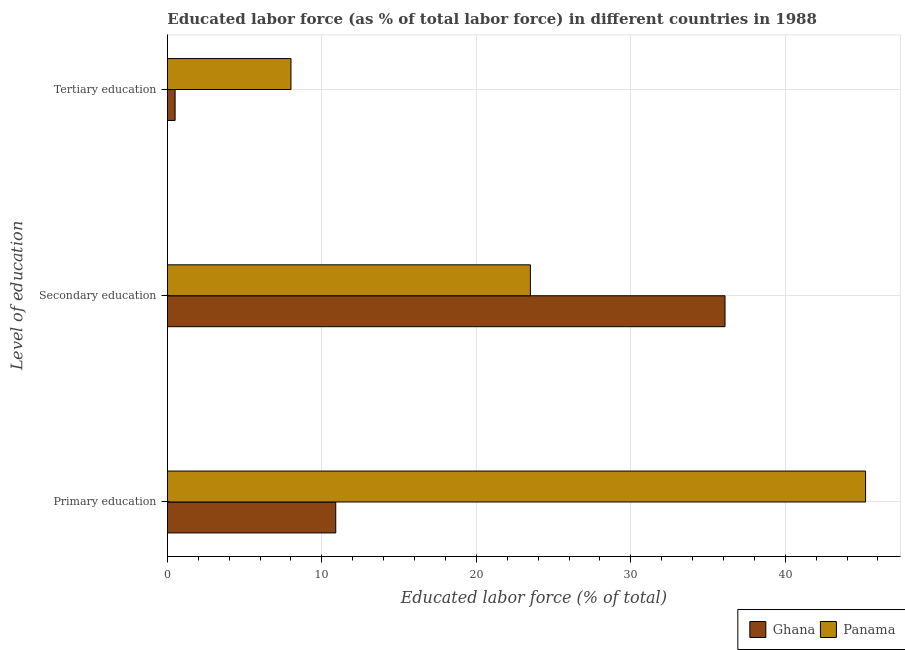How many different coloured bars are there?
Keep it short and to the point. 2. How many groups of bars are there?
Offer a terse response. 3. Are the number of bars per tick equal to the number of legend labels?
Provide a succinct answer. Yes. Are the number of bars on each tick of the Y-axis equal?
Provide a short and direct response. Yes. How many bars are there on the 2nd tick from the top?
Offer a very short reply. 2. How many bars are there on the 2nd tick from the bottom?
Your response must be concise. 2. What is the label of the 3rd group of bars from the top?
Ensure brevity in your answer.  Primary education. Across all countries, what is the maximum percentage of labor force who received secondary education?
Your answer should be compact. 36.1. Across all countries, what is the minimum percentage of labor force who received tertiary education?
Provide a succinct answer. 0.5. What is the total percentage of labor force who received tertiary education in the graph?
Offer a very short reply. 8.5. What is the difference between the percentage of labor force who received tertiary education in Ghana and that in Panama?
Your answer should be compact. -7.5. What is the difference between the percentage of labor force who received primary education in Ghana and the percentage of labor force who received tertiary education in Panama?
Your response must be concise. 2.9. What is the average percentage of labor force who received primary education per country?
Your response must be concise. 28.05. What is the difference between the percentage of labor force who received primary education and percentage of labor force who received secondary education in Panama?
Provide a short and direct response. 21.7. What is the ratio of the percentage of labor force who received primary education in Ghana to that in Panama?
Offer a very short reply. 0.24. Is the sum of the percentage of labor force who received primary education in Ghana and Panama greater than the maximum percentage of labor force who received tertiary education across all countries?
Your answer should be compact. Yes. What does the 2nd bar from the bottom in Secondary education represents?
Ensure brevity in your answer.  Panama. Are all the bars in the graph horizontal?
Keep it short and to the point. Yes. Are the values on the major ticks of X-axis written in scientific E-notation?
Make the answer very short. No. Does the graph contain any zero values?
Offer a very short reply. No. Does the graph contain grids?
Provide a short and direct response. Yes. Where does the legend appear in the graph?
Offer a very short reply. Bottom right. What is the title of the graph?
Offer a terse response. Educated labor force (as % of total labor force) in different countries in 1988. Does "Iceland" appear as one of the legend labels in the graph?
Provide a short and direct response. No. What is the label or title of the X-axis?
Offer a terse response. Educated labor force (% of total). What is the label or title of the Y-axis?
Offer a terse response. Level of education. What is the Educated labor force (% of total) in Ghana in Primary education?
Your answer should be very brief. 10.9. What is the Educated labor force (% of total) in Panama in Primary education?
Ensure brevity in your answer.  45.2. What is the Educated labor force (% of total) of Ghana in Secondary education?
Your answer should be compact. 36.1. Across all Level of education, what is the maximum Educated labor force (% of total) of Ghana?
Ensure brevity in your answer.  36.1. Across all Level of education, what is the maximum Educated labor force (% of total) of Panama?
Offer a terse response. 45.2. Across all Level of education, what is the minimum Educated labor force (% of total) of Ghana?
Your answer should be very brief. 0.5. Across all Level of education, what is the minimum Educated labor force (% of total) of Panama?
Offer a very short reply. 8. What is the total Educated labor force (% of total) of Ghana in the graph?
Offer a terse response. 47.5. What is the total Educated labor force (% of total) of Panama in the graph?
Make the answer very short. 76.7. What is the difference between the Educated labor force (% of total) in Ghana in Primary education and that in Secondary education?
Give a very brief answer. -25.2. What is the difference between the Educated labor force (% of total) in Panama in Primary education and that in Secondary education?
Ensure brevity in your answer.  21.7. What is the difference between the Educated labor force (% of total) of Ghana in Primary education and that in Tertiary education?
Your answer should be compact. 10.4. What is the difference between the Educated labor force (% of total) of Panama in Primary education and that in Tertiary education?
Your answer should be very brief. 37.2. What is the difference between the Educated labor force (% of total) in Ghana in Secondary education and that in Tertiary education?
Your answer should be compact. 35.6. What is the difference between the Educated labor force (% of total) in Panama in Secondary education and that in Tertiary education?
Provide a succinct answer. 15.5. What is the difference between the Educated labor force (% of total) of Ghana in Primary education and the Educated labor force (% of total) of Panama in Secondary education?
Keep it short and to the point. -12.6. What is the difference between the Educated labor force (% of total) of Ghana in Secondary education and the Educated labor force (% of total) of Panama in Tertiary education?
Your answer should be compact. 28.1. What is the average Educated labor force (% of total) of Ghana per Level of education?
Your answer should be compact. 15.83. What is the average Educated labor force (% of total) of Panama per Level of education?
Offer a very short reply. 25.57. What is the difference between the Educated labor force (% of total) of Ghana and Educated labor force (% of total) of Panama in Primary education?
Offer a terse response. -34.3. What is the ratio of the Educated labor force (% of total) in Ghana in Primary education to that in Secondary education?
Provide a succinct answer. 0.3. What is the ratio of the Educated labor force (% of total) in Panama in Primary education to that in Secondary education?
Offer a very short reply. 1.92. What is the ratio of the Educated labor force (% of total) of Ghana in Primary education to that in Tertiary education?
Your answer should be compact. 21.8. What is the ratio of the Educated labor force (% of total) of Panama in Primary education to that in Tertiary education?
Provide a succinct answer. 5.65. What is the ratio of the Educated labor force (% of total) in Ghana in Secondary education to that in Tertiary education?
Offer a terse response. 72.2. What is the ratio of the Educated labor force (% of total) of Panama in Secondary education to that in Tertiary education?
Your response must be concise. 2.94. What is the difference between the highest and the second highest Educated labor force (% of total) of Ghana?
Make the answer very short. 25.2. What is the difference between the highest and the second highest Educated labor force (% of total) in Panama?
Your answer should be very brief. 21.7. What is the difference between the highest and the lowest Educated labor force (% of total) in Ghana?
Give a very brief answer. 35.6. What is the difference between the highest and the lowest Educated labor force (% of total) of Panama?
Your answer should be compact. 37.2. 